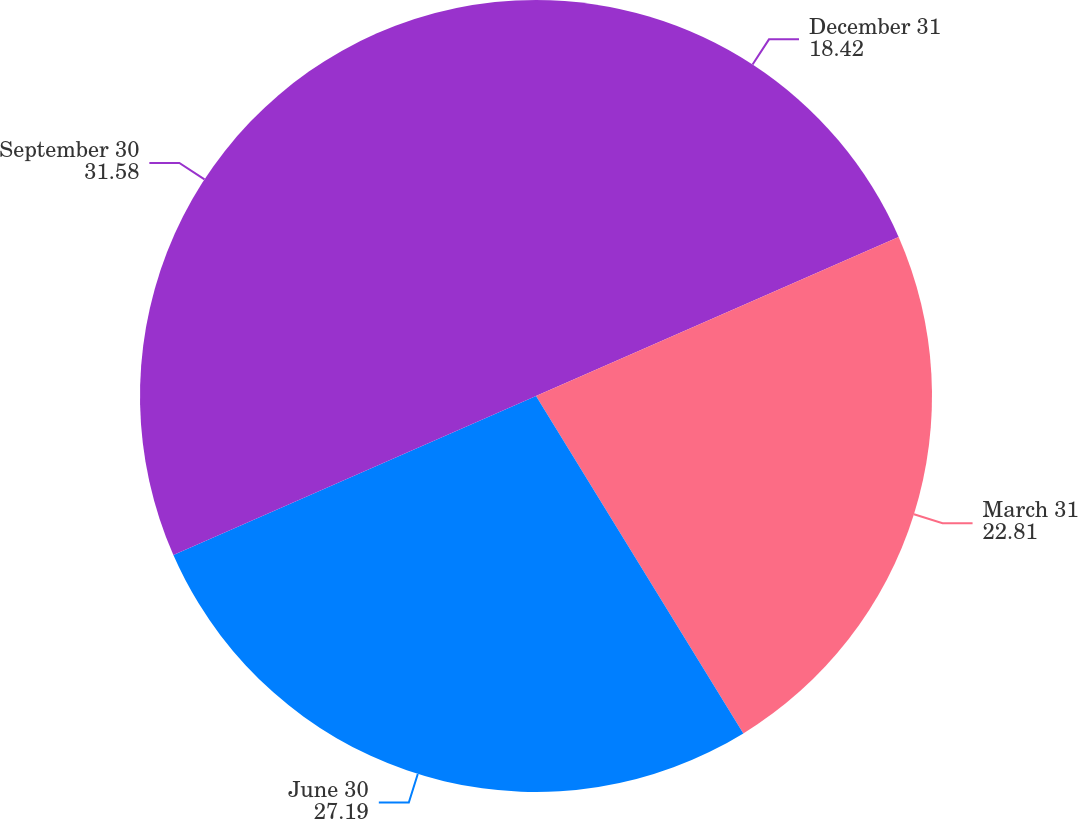Convert chart to OTSL. <chart><loc_0><loc_0><loc_500><loc_500><pie_chart><fcel>December 31<fcel>March 31<fcel>June 30<fcel>September 30<nl><fcel>18.42%<fcel>22.81%<fcel>27.19%<fcel>31.58%<nl></chart> 